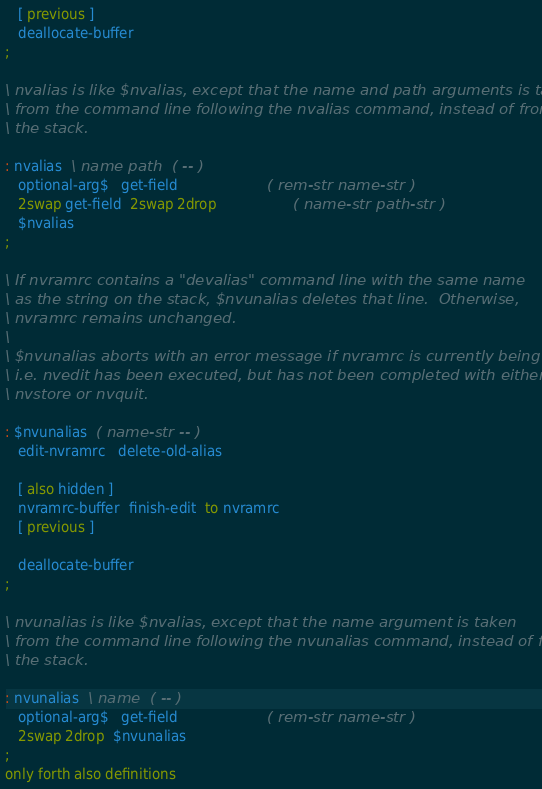<code> <loc_0><loc_0><loc_500><loc_500><_Forth_>
   [ previous ]
   deallocate-buffer
;

\ nvalias is like $nvalias, except that the name and path arguments is taken
\ from the command line following the nvalias command, instead of from
\ the stack.

: nvalias  \ name path  ( -- )
   optional-arg$   get-field                     ( rem-str name-str )
   2swap get-field  2swap 2drop                  ( name-str path-str )
   $nvalias
;

\ If nvramrc contains a "devalias" command line with the same name
\ as the string on the stack, $nvunalias deletes that line.  Otherwise,
\ nvramrc remains unchanged.
\
\ $nvunalias aborts with an error message if nvramrc is currently being edited,
\ i.e. nvedit has been executed, but has not been completed with either
\ nvstore or nvquit.

: $nvunalias  ( name-str -- )
   edit-nvramrc   delete-old-alias

   [ also hidden ]
   nvramrc-buffer  finish-edit  to nvramrc
   [ previous ]

   deallocate-buffer
;

\ nvunalias is like $nvalias, except that the name argument is taken
\ from the command line following the nvunalias command, instead of from
\ the stack.

: nvunalias  \ name  ( -- )
   optional-arg$   get-field                     ( rem-str name-str )
   2swap 2drop  $nvunalias
;
only forth also definitions

</code> 